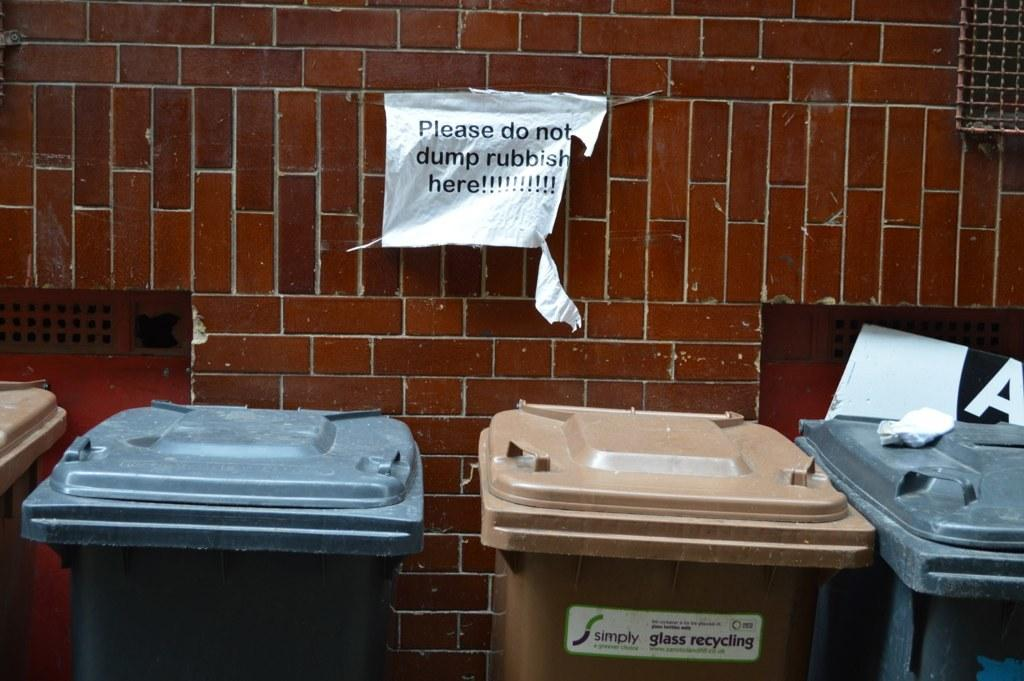<image>
Describe the image concisely. A sign behind a row of trash cans ask that rubbish not be dumped at that location. 